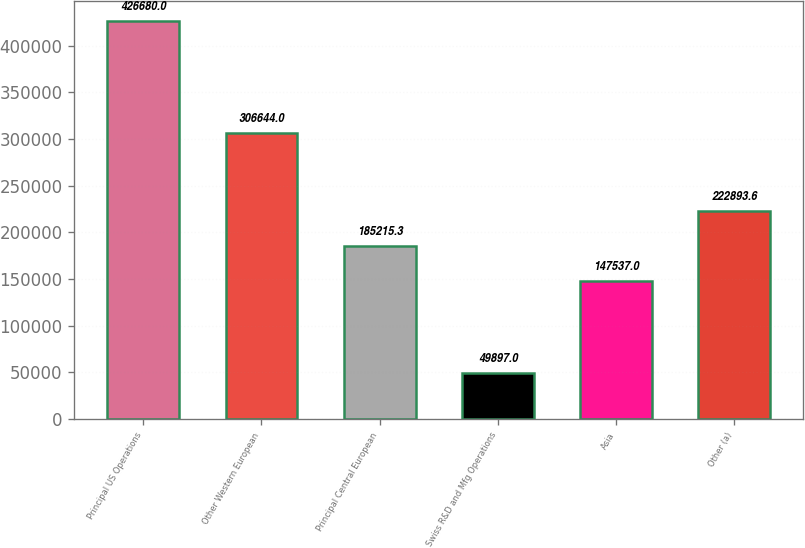<chart> <loc_0><loc_0><loc_500><loc_500><bar_chart><fcel>Principal US Operations<fcel>Other Western European<fcel>Principal Central European<fcel>Swiss R&D and Mfg Operations<fcel>Asia<fcel>Other (a)<nl><fcel>426680<fcel>306644<fcel>185215<fcel>49897<fcel>147537<fcel>222894<nl></chart> 